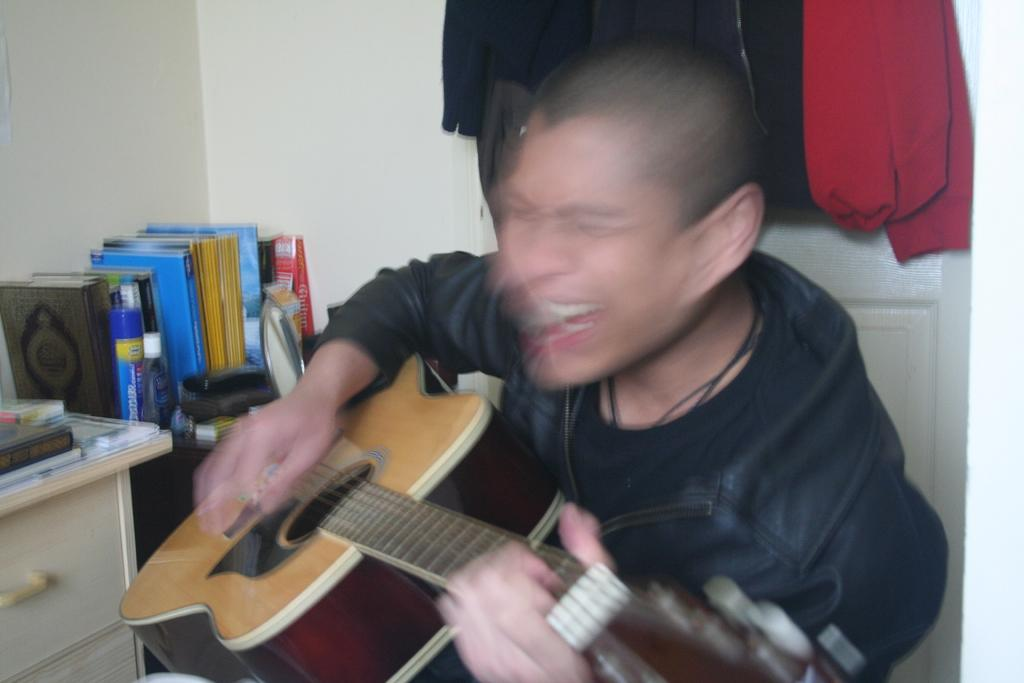What is the person in the image doing? There is a person playing a guitar in the image. What objects can be seen near a table in the image? There are books beside a table in the image. Where are clothes visible in the image? Clothes are visible at the right top of the image. What type of key is used to play the guitar in the image? There is no key involved in playing the guitar in the image; it is played using the person's fingers. 